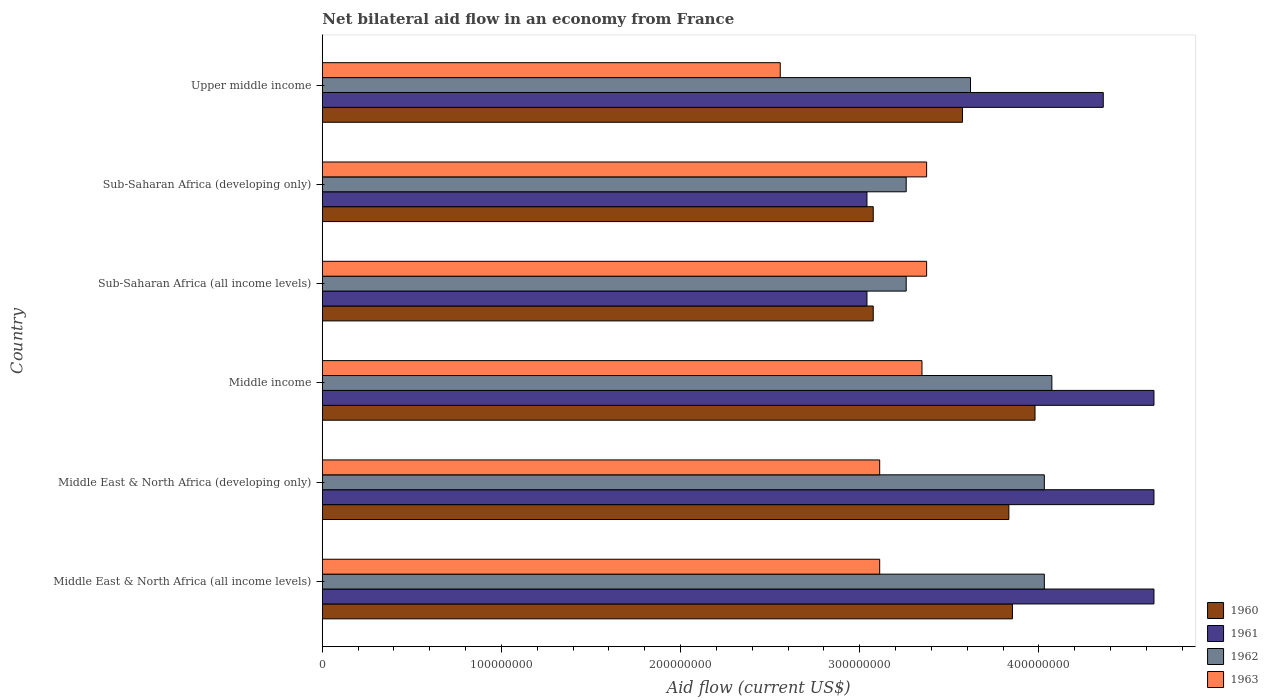Are the number of bars per tick equal to the number of legend labels?
Your answer should be compact. Yes. Are the number of bars on each tick of the Y-axis equal?
Offer a very short reply. Yes. How many bars are there on the 4th tick from the top?
Ensure brevity in your answer.  4. How many bars are there on the 2nd tick from the bottom?
Keep it short and to the point. 4. What is the label of the 5th group of bars from the top?
Make the answer very short. Middle East & North Africa (developing only). In how many cases, is the number of bars for a given country not equal to the number of legend labels?
Give a very brief answer. 0. What is the net bilateral aid flow in 1962 in Sub-Saharan Africa (all income levels)?
Give a very brief answer. 3.26e+08. Across all countries, what is the maximum net bilateral aid flow in 1962?
Provide a short and direct response. 4.07e+08. Across all countries, what is the minimum net bilateral aid flow in 1962?
Your answer should be very brief. 3.26e+08. In which country was the net bilateral aid flow in 1961 maximum?
Provide a short and direct response. Middle East & North Africa (all income levels). In which country was the net bilateral aid flow in 1962 minimum?
Ensure brevity in your answer.  Sub-Saharan Africa (all income levels). What is the total net bilateral aid flow in 1961 in the graph?
Make the answer very short. 2.44e+09. What is the difference between the net bilateral aid flow in 1962 in Middle East & North Africa (developing only) and that in Middle income?
Ensure brevity in your answer.  -4.20e+06. What is the difference between the net bilateral aid flow in 1960 in Middle income and the net bilateral aid flow in 1963 in Middle East & North Africa (developing only)?
Offer a terse response. 8.67e+07. What is the average net bilateral aid flow in 1960 per country?
Provide a short and direct response. 3.56e+08. What is the difference between the net bilateral aid flow in 1961 and net bilateral aid flow in 1963 in Middle East & North Africa (developing only)?
Keep it short and to the point. 1.53e+08. In how many countries, is the net bilateral aid flow in 1960 greater than 220000000 US$?
Make the answer very short. 6. What is the ratio of the net bilateral aid flow in 1961 in Middle income to that in Sub-Saharan Africa (all income levels)?
Your answer should be very brief. 1.53. Is the difference between the net bilateral aid flow in 1961 in Middle East & North Africa (all income levels) and Upper middle income greater than the difference between the net bilateral aid flow in 1963 in Middle East & North Africa (all income levels) and Upper middle income?
Give a very brief answer. No. What is the difference between the highest and the second highest net bilateral aid flow in 1962?
Offer a very short reply. 4.20e+06. What is the difference between the highest and the lowest net bilateral aid flow in 1960?
Keep it short and to the point. 9.03e+07. Is it the case that in every country, the sum of the net bilateral aid flow in 1962 and net bilateral aid flow in 1960 is greater than the sum of net bilateral aid flow in 1963 and net bilateral aid flow in 1961?
Provide a short and direct response. Yes. What does the 3rd bar from the top in Sub-Saharan Africa (all income levels) represents?
Provide a succinct answer. 1961. Is it the case that in every country, the sum of the net bilateral aid flow in 1962 and net bilateral aid flow in 1963 is greater than the net bilateral aid flow in 1961?
Your answer should be very brief. Yes. How many countries are there in the graph?
Provide a short and direct response. 6. Does the graph contain grids?
Give a very brief answer. No. How many legend labels are there?
Your answer should be compact. 4. How are the legend labels stacked?
Make the answer very short. Vertical. What is the title of the graph?
Keep it short and to the point. Net bilateral aid flow in an economy from France. What is the Aid flow (current US$) of 1960 in Middle East & North Africa (all income levels)?
Your response must be concise. 3.85e+08. What is the Aid flow (current US$) in 1961 in Middle East & North Africa (all income levels)?
Provide a succinct answer. 4.64e+08. What is the Aid flow (current US$) of 1962 in Middle East & North Africa (all income levels)?
Offer a very short reply. 4.03e+08. What is the Aid flow (current US$) in 1963 in Middle East & North Africa (all income levels)?
Provide a succinct answer. 3.11e+08. What is the Aid flow (current US$) of 1960 in Middle East & North Africa (developing only)?
Ensure brevity in your answer.  3.83e+08. What is the Aid flow (current US$) in 1961 in Middle East & North Africa (developing only)?
Your answer should be very brief. 4.64e+08. What is the Aid flow (current US$) in 1962 in Middle East & North Africa (developing only)?
Ensure brevity in your answer.  4.03e+08. What is the Aid flow (current US$) of 1963 in Middle East & North Africa (developing only)?
Your response must be concise. 3.11e+08. What is the Aid flow (current US$) in 1960 in Middle income?
Keep it short and to the point. 3.98e+08. What is the Aid flow (current US$) in 1961 in Middle income?
Your answer should be very brief. 4.64e+08. What is the Aid flow (current US$) of 1962 in Middle income?
Provide a succinct answer. 4.07e+08. What is the Aid flow (current US$) in 1963 in Middle income?
Offer a terse response. 3.35e+08. What is the Aid flow (current US$) in 1960 in Sub-Saharan Africa (all income levels)?
Offer a terse response. 3.08e+08. What is the Aid flow (current US$) in 1961 in Sub-Saharan Africa (all income levels)?
Make the answer very short. 3.04e+08. What is the Aid flow (current US$) in 1962 in Sub-Saharan Africa (all income levels)?
Make the answer very short. 3.26e+08. What is the Aid flow (current US$) in 1963 in Sub-Saharan Africa (all income levels)?
Offer a very short reply. 3.37e+08. What is the Aid flow (current US$) in 1960 in Sub-Saharan Africa (developing only)?
Your response must be concise. 3.08e+08. What is the Aid flow (current US$) in 1961 in Sub-Saharan Africa (developing only)?
Give a very brief answer. 3.04e+08. What is the Aid flow (current US$) of 1962 in Sub-Saharan Africa (developing only)?
Ensure brevity in your answer.  3.26e+08. What is the Aid flow (current US$) of 1963 in Sub-Saharan Africa (developing only)?
Make the answer very short. 3.37e+08. What is the Aid flow (current US$) in 1960 in Upper middle income?
Provide a succinct answer. 3.57e+08. What is the Aid flow (current US$) in 1961 in Upper middle income?
Give a very brief answer. 4.36e+08. What is the Aid flow (current US$) in 1962 in Upper middle income?
Keep it short and to the point. 3.62e+08. What is the Aid flow (current US$) in 1963 in Upper middle income?
Make the answer very short. 2.56e+08. Across all countries, what is the maximum Aid flow (current US$) in 1960?
Your answer should be very brief. 3.98e+08. Across all countries, what is the maximum Aid flow (current US$) of 1961?
Provide a short and direct response. 4.64e+08. Across all countries, what is the maximum Aid flow (current US$) in 1962?
Keep it short and to the point. 4.07e+08. Across all countries, what is the maximum Aid flow (current US$) of 1963?
Your response must be concise. 3.37e+08. Across all countries, what is the minimum Aid flow (current US$) of 1960?
Your answer should be compact. 3.08e+08. Across all countries, what is the minimum Aid flow (current US$) in 1961?
Your answer should be very brief. 3.04e+08. Across all countries, what is the minimum Aid flow (current US$) in 1962?
Ensure brevity in your answer.  3.26e+08. Across all countries, what is the minimum Aid flow (current US$) in 1963?
Provide a succinct answer. 2.56e+08. What is the total Aid flow (current US$) in 1960 in the graph?
Offer a very short reply. 2.14e+09. What is the total Aid flow (current US$) of 1961 in the graph?
Your answer should be very brief. 2.44e+09. What is the total Aid flow (current US$) in 1962 in the graph?
Ensure brevity in your answer.  2.23e+09. What is the total Aid flow (current US$) in 1963 in the graph?
Your answer should be very brief. 1.89e+09. What is the difference between the Aid flow (current US$) of 1961 in Middle East & North Africa (all income levels) and that in Middle East & North Africa (developing only)?
Make the answer very short. 0. What is the difference between the Aid flow (current US$) in 1960 in Middle East & North Africa (all income levels) and that in Middle income?
Give a very brief answer. -1.26e+07. What is the difference between the Aid flow (current US$) of 1961 in Middle East & North Africa (all income levels) and that in Middle income?
Give a very brief answer. 0. What is the difference between the Aid flow (current US$) of 1962 in Middle East & North Africa (all income levels) and that in Middle income?
Keep it short and to the point. -4.20e+06. What is the difference between the Aid flow (current US$) of 1963 in Middle East & North Africa (all income levels) and that in Middle income?
Offer a very short reply. -2.36e+07. What is the difference between the Aid flow (current US$) in 1960 in Middle East & North Africa (all income levels) and that in Sub-Saharan Africa (all income levels)?
Your response must be concise. 7.77e+07. What is the difference between the Aid flow (current US$) of 1961 in Middle East & North Africa (all income levels) and that in Sub-Saharan Africa (all income levels)?
Your answer should be compact. 1.60e+08. What is the difference between the Aid flow (current US$) of 1962 in Middle East & North Africa (all income levels) and that in Sub-Saharan Africa (all income levels)?
Give a very brief answer. 7.71e+07. What is the difference between the Aid flow (current US$) of 1963 in Middle East & North Africa (all income levels) and that in Sub-Saharan Africa (all income levels)?
Make the answer very short. -2.62e+07. What is the difference between the Aid flow (current US$) in 1960 in Middle East & North Africa (all income levels) and that in Sub-Saharan Africa (developing only)?
Give a very brief answer. 7.77e+07. What is the difference between the Aid flow (current US$) of 1961 in Middle East & North Africa (all income levels) and that in Sub-Saharan Africa (developing only)?
Your answer should be compact. 1.60e+08. What is the difference between the Aid flow (current US$) of 1962 in Middle East & North Africa (all income levels) and that in Sub-Saharan Africa (developing only)?
Your response must be concise. 7.71e+07. What is the difference between the Aid flow (current US$) in 1963 in Middle East & North Africa (all income levels) and that in Sub-Saharan Africa (developing only)?
Offer a terse response. -2.62e+07. What is the difference between the Aid flow (current US$) in 1960 in Middle East & North Africa (all income levels) and that in Upper middle income?
Offer a very short reply. 2.79e+07. What is the difference between the Aid flow (current US$) in 1961 in Middle East & North Africa (all income levels) and that in Upper middle income?
Your answer should be compact. 2.83e+07. What is the difference between the Aid flow (current US$) in 1962 in Middle East & North Africa (all income levels) and that in Upper middle income?
Keep it short and to the point. 4.12e+07. What is the difference between the Aid flow (current US$) in 1963 in Middle East & North Africa (all income levels) and that in Upper middle income?
Your response must be concise. 5.55e+07. What is the difference between the Aid flow (current US$) in 1960 in Middle East & North Africa (developing only) and that in Middle income?
Your response must be concise. -1.46e+07. What is the difference between the Aid flow (current US$) in 1962 in Middle East & North Africa (developing only) and that in Middle income?
Your answer should be very brief. -4.20e+06. What is the difference between the Aid flow (current US$) in 1963 in Middle East & North Africa (developing only) and that in Middle income?
Your answer should be compact. -2.36e+07. What is the difference between the Aid flow (current US$) in 1960 in Middle East & North Africa (developing only) and that in Sub-Saharan Africa (all income levels)?
Your answer should be compact. 7.57e+07. What is the difference between the Aid flow (current US$) of 1961 in Middle East & North Africa (developing only) and that in Sub-Saharan Africa (all income levels)?
Offer a very short reply. 1.60e+08. What is the difference between the Aid flow (current US$) of 1962 in Middle East & North Africa (developing only) and that in Sub-Saharan Africa (all income levels)?
Offer a very short reply. 7.71e+07. What is the difference between the Aid flow (current US$) in 1963 in Middle East & North Africa (developing only) and that in Sub-Saharan Africa (all income levels)?
Make the answer very short. -2.62e+07. What is the difference between the Aid flow (current US$) in 1960 in Middle East & North Africa (developing only) and that in Sub-Saharan Africa (developing only)?
Your answer should be compact. 7.57e+07. What is the difference between the Aid flow (current US$) of 1961 in Middle East & North Africa (developing only) and that in Sub-Saharan Africa (developing only)?
Your answer should be compact. 1.60e+08. What is the difference between the Aid flow (current US$) in 1962 in Middle East & North Africa (developing only) and that in Sub-Saharan Africa (developing only)?
Make the answer very short. 7.71e+07. What is the difference between the Aid flow (current US$) in 1963 in Middle East & North Africa (developing only) and that in Sub-Saharan Africa (developing only)?
Provide a short and direct response. -2.62e+07. What is the difference between the Aid flow (current US$) of 1960 in Middle East & North Africa (developing only) and that in Upper middle income?
Give a very brief answer. 2.59e+07. What is the difference between the Aid flow (current US$) in 1961 in Middle East & North Africa (developing only) and that in Upper middle income?
Ensure brevity in your answer.  2.83e+07. What is the difference between the Aid flow (current US$) of 1962 in Middle East & North Africa (developing only) and that in Upper middle income?
Ensure brevity in your answer.  4.12e+07. What is the difference between the Aid flow (current US$) in 1963 in Middle East & North Africa (developing only) and that in Upper middle income?
Provide a succinct answer. 5.55e+07. What is the difference between the Aid flow (current US$) of 1960 in Middle income and that in Sub-Saharan Africa (all income levels)?
Keep it short and to the point. 9.03e+07. What is the difference between the Aid flow (current US$) of 1961 in Middle income and that in Sub-Saharan Africa (all income levels)?
Provide a succinct answer. 1.60e+08. What is the difference between the Aid flow (current US$) of 1962 in Middle income and that in Sub-Saharan Africa (all income levels)?
Offer a very short reply. 8.13e+07. What is the difference between the Aid flow (current US$) of 1963 in Middle income and that in Sub-Saharan Africa (all income levels)?
Ensure brevity in your answer.  -2.60e+06. What is the difference between the Aid flow (current US$) of 1960 in Middle income and that in Sub-Saharan Africa (developing only)?
Your answer should be very brief. 9.03e+07. What is the difference between the Aid flow (current US$) in 1961 in Middle income and that in Sub-Saharan Africa (developing only)?
Offer a very short reply. 1.60e+08. What is the difference between the Aid flow (current US$) of 1962 in Middle income and that in Sub-Saharan Africa (developing only)?
Provide a short and direct response. 8.13e+07. What is the difference between the Aid flow (current US$) of 1963 in Middle income and that in Sub-Saharan Africa (developing only)?
Offer a terse response. -2.60e+06. What is the difference between the Aid flow (current US$) of 1960 in Middle income and that in Upper middle income?
Ensure brevity in your answer.  4.05e+07. What is the difference between the Aid flow (current US$) of 1961 in Middle income and that in Upper middle income?
Provide a succinct answer. 2.83e+07. What is the difference between the Aid flow (current US$) in 1962 in Middle income and that in Upper middle income?
Provide a short and direct response. 4.54e+07. What is the difference between the Aid flow (current US$) of 1963 in Middle income and that in Upper middle income?
Your answer should be very brief. 7.91e+07. What is the difference between the Aid flow (current US$) in 1960 in Sub-Saharan Africa (all income levels) and that in Sub-Saharan Africa (developing only)?
Provide a short and direct response. 0. What is the difference between the Aid flow (current US$) of 1961 in Sub-Saharan Africa (all income levels) and that in Sub-Saharan Africa (developing only)?
Give a very brief answer. 0. What is the difference between the Aid flow (current US$) of 1962 in Sub-Saharan Africa (all income levels) and that in Sub-Saharan Africa (developing only)?
Offer a terse response. 0. What is the difference between the Aid flow (current US$) in 1960 in Sub-Saharan Africa (all income levels) and that in Upper middle income?
Provide a succinct answer. -4.98e+07. What is the difference between the Aid flow (current US$) in 1961 in Sub-Saharan Africa (all income levels) and that in Upper middle income?
Your response must be concise. -1.32e+08. What is the difference between the Aid flow (current US$) in 1962 in Sub-Saharan Africa (all income levels) and that in Upper middle income?
Provide a short and direct response. -3.59e+07. What is the difference between the Aid flow (current US$) in 1963 in Sub-Saharan Africa (all income levels) and that in Upper middle income?
Your answer should be very brief. 8.17e+07. What is the difference between the Aid flow (current US$) in 1960 in Sub-Saharan Africa (developing only) and that in Upper middle income?
Ensure brevity in your answer.  -4.98e+07. What is the difference between the Aid flow (current US$) in 1961 in Sub-Saharan Africa (developing only) and that in Upper middle income?
Give a very brief answer. -1.32e+08. What is the difference between the Aid flow (current US$) of 1962 in Sub-Saharan Africa (developing only) and that in Upper middle income?
Provide a succinct answer. -3.59e+07. What is the difference between the Aid flow (current US$) of 1963 in Sub-Saharan Africa (developing only) and that in Upper middle income?
Offer a terse response. 8.17e+07. What is the difference between the Aid flow (current US$) of 1960 in Middle East & North Africa (all income levels) and the Aid flow (current US$) of 1961 in Middle East & North Africa (developing only)?
Your response must be concise. -7.90e+07. What is the difference between the Aid flow (current US$) in 1960 in Middle East & North Africa (all income levels) and the Aid flow (current US$) in 1962 in Middle East & North Africa (developing only)?
Offer a very short reply. -1.78e+07. What is the difference between the Aid flow (current US$) in 1960 in Middle East & North Africa (all income levels) and the Aid flow (current US$) in 1963 in Middle East & North Africa (developing only)?
Offer a very short reply. 7.41e+07. What is the difference between the Aid flow (current US$) of 1961 in Middle East & North Africa (all income levels) and the Aid flow (current US$) of 1962 in Middle East & North Africa (developing only)?
Make the answer very short. 6.12e+07. What is the difference between the Aid flow (current US$) in 1961 in Middle East & North Africa (all income levels) and the Aid flow (current US$) in 1963 in Middle East & North Africa (developing only)?
Keep it short and to the point. 1.53e+08. What is the difference between the Aid flow (current US$) of 1962 in Middle East & North Africa (all income levels) and the Aid flow (current US$) of 1963 in Middle East & North Africa (developing only)?
Keep it short and to the point. 9.19e+07. What is the difference between the Aid flow (current US$) in 1960 in Middle East & North Africa (all income levels) and the Aid flow (current US$) in 1961 in Middle income?
Your response must be concise. -7.90e+07. What is the difference between the Aid flow (current US$) of 1960 in Middle East & North Africa (all income levels) and the Aid flow (current US$) of 1962 in Middle income?
Offer a very short reply. -2.20e+07. What is the difference between the Aid flow (current US$) in 1960 in Middle East & North Africa (all income levels) and the Aid flow (current US$) in 1963 in Middle income?
Your answer should be compact. 5.05e+07. What is the difference between the Aid flow (current US$) of 1961 in Middle East & North Africa (all income levels) and the Aid flow (current US$) of 1962 in Middle income?
Keep it short and to the point. 5.70e+07. What is the difference between the Aid flow (current US$) in 1961 in Middle East & North Africa (all income levels) and the Aid flow (current US$) in 1963 in Middle income?
Your answer should be compact. 1.30e+08. What is the difference between the Aid flow (current US$) in 1962 in Middle East & North Africa (all income levels) and the Aid flow (current US$) in 1963 in Middle income?
Your response must be concise. 6.83e+07. What is the difference between the Aid flow (current US$) of 1960 in Middle East & North Africa (all income levels) and the Aid flow (current US$) of 1961 in Sub-Saharan Africa (all income levels)?
Your answer should be very brief. 8.12e+07. What is the difference between the Aid flow (current US$) in 1960 in Middle East & North Africa (all income levels) and the Aid flow (current US$) in 1962 in Sub-Saharan Africa (all income levels)?
Provide a succinct answer. 5.93e+07. What is the difference between the Aid flow (current US$) of 1960 in Middle East & North Africa (all income levels) and the Aid flow (current US$) of 1963 in Sub-Saharan Africa (all income levels)?
Keep it short and to the point. 4.79e+07. What is the difference between the Aid flow (current US$) in 1961 in Middle East & North Africa (all income levels) and the Aid flow (current US$) in 1962 in Sub-Saharan Africa (all income levels)?
Provide a short and direct response. 1.38e+08. What is the difference between the Aid flow (current US$) of 1961 in Middle East & North Africa (all income levels) and the Aid flow (current US$) of 1963 in Sub-Saharan Africa (all income levels)?
Offer a terse response. 1.27e+08. What is the difference between the Aid flow (current US$) of 1962 in Middle East & North Africa (all income levels) and the Aid flow (current US$) of 1963 in Sub-Saharan Africa (all income levels)?
Your answer should be compact. 6.57e+07. What is the difference between the Aid flow (current US$) in 1960 in Middle East & North Africa (all income levels) and the Aid flow (current US$) in 1961 in Sub-Saharan Africa (developing only)?
Ensure brevity in your answer.  8.12e+07. What is the difference between the Aid flow (current US$) of 1960 in Middle East & North Africa (all income levels) and the Aid flow (current US$) of 1962 in Sub-Saharan Africa (developing only)?
Give a very brief answer. 5.93e+07. What is the difference between the Aid flow (current US$) of 1960 in Middle East & North Africa (all income levels) and the Aid flow (current US$) of 1963 in Sub-Saharan Africa (developing only)?
Give a very brief answer. 4.79e+07. What is the difference between the Aid flow (current US$) in 1961 in Middle East & North Africa (all income levels) and the Aid flow (current US$) in 1962 in Sub-Saharan Africa (developing only)?
Offer a terse response. 1.38e+08. What is the difference between the Aid flow (current US$) in 1961 in Middle East & North Africa (all income levels) and the Aid flow (current US$) in 1963 in Sub-Saharan Africa (developing only)?
Your response must be concise. 1.27e+08. What is the difference between the Aid flow (current US$) of 1962 in Middle East & North Africa (all income levels) and the Aid flow (current US$) of 1963 in Sub-Saharan Africa (developing only)?
Provide a succinct answer. 6.57e+07. What is the difference between the Aid flow (current US$) of 1960 in Middle East & North Africa (all income levels) and the Aid flow (current US$) of 1961 in Upper middle income?
Ensure brevity in your answer.  -5.07e+07. What is the difference between the Aid flow (current US$) in 1960 in Middle East & North Africa (all income levels) and the Aid flow (current US$) in 1962 in Upper middle income?
Make the answer very short. 2.34e+07. What is the difference between the Aid flow (current US$) of 1960 in Middle East & North Africa (all income levels) and the Aid flow (current US$) of 1963 in Upper middle income?
Provide a succinct answer. 1.30e+08. What is the difference between the Aid flow (current US$) in 1961 in Middle East & North Africa (all income levels) and the Aid flow (current US$) in 1962 in Upper middle income?
Ensure brevity in your answer.  1.02e+08. What is the difference between the Aid flow (current US$) of 1961 in Middle East & North Africa (all income levels) and the Aid flow (current US$) of 1963 in Upper middle income?
Offer a terse response. 2.09e+08. What is the difference between the Aid flow (current US$) in 1962 in Middle East & North Africa (all income levels) and the Aid flow (current US$) in 1963 in Upper middle income?
Your response must be concise. 1.47e+08. What is the difference between the Aid flow (current US$) in 1960 in Middle East & North Africa (developing only) and the Aid flow (current US$) in 1961 in Middle income?
Provide a succinct answer. -8.10e+07. What is the difference between the Aid flow (current US$) in 1960 in Middle East & North Africa (developing only) and the Aid flow (current US$) in 1962 in Middle income?
Provide a succinct answer. -2.40e+07. What is the difference between the Aid flow (current US$) in 1960 in Middle East & North Africa (developing only) and the Aid flow (current US$) in 1963 in Middle income?
Give a very brief answer. 4.85e+07. What is the difference between the Aid flow (current US$) in 1961 in Middle East & North Africa (developing only) and the Aid flow (current US$) in 1962 in Middle income?
Provide a succinct answer. 5.70e+07. What is the difference between the Aid flow (current US$) in 1961 in Middle East & North Africa (developing only) and the Aid flow (current US$) in 1963 in Middle income?
Ensure brevity in your answer.  1.30e+08. What is the difference between the Aid flow (current US$) of 1962 in Middle East & North Africa (developing only) and the Aid flow (current US$) of 1963 in Middle income?
Ensure brevity in your answer.  6.83e+07. What is the difference between the Aid flow (current US$) in 1960 in Middle East & North Africa (developing only) and the Aid flow (current US$) in 1961 in Sub-Saharan Africa (all income levels)?
Offer a terse response. 7.92e+07. What is the difference between the Aid flow (current US$) of 1960 in Middle East & North Africa (developing only) and the Aid flow (current US$) of 1962 in Sub-Saharan Africa (all income levels)?
Give a very brief answer. 5.73e+07. What is the difference between the Aid flow (current US$) of 1960 in Middle East & North Africa (developing only) and the Aid flow (current US$) of 1963 in Sub-Saharan Africa (all income levels)?
Your response must be concise. 4.59e+07. What is the difference between the Aid flow (current US$) of 1961 in Middle East & North Africa (developing only) and the Aid flow (current US$) of 1962 in Sub-Saharan Africa (all income levels)?
Ensure brevity in your answer.  1.38e+08. What is the difference between the Aid flow (current US$) in 1961 in Middle East & North Africa (developing only) and the Aid flow (current US$) in 1963 in Sub-Saharan Africa (all income levels)?
Ensure brevity in your answer.  1.27e+08. What is the difference between the Aid flow (current US$) in 1962 in Middle East & North Africa (developing only) and the Aid flow (current US$) in 1963 in Sub-Saharan Africa (all income levels)?
Provide a short and direct response. 6.57e+07. What is the difference between the Aid flow (current US$) of 1960 in Middle East & North Africa (developing only) and the Aid flow (current US$) of 1961 in Sub-Saharan Africa (developing only)?
Offer a very short reply. 7.92e+07. What is the difference between the Aid flow (current US$) of 1960 in Middle East & North Africa (developing only) and the Aid flow (current US$) of 1962 in Sub-Saharan Africa (developing only)?
Keep it short and to the point. 5.73e+07. What is the difference between the Aid flow (current US$) of 1960 in Middle East & North Africa (developing only) and the Aid flow (current US$) of 1963 in Sub-Saharan Africa (developing only)?
Provide a short and direct response. 4.59e+07. What is the difference between the Aid flow (current US$) in 1961 in Middle East & North Africa (developing only) and the Aid flow (current US$) in 1962 in Sub-Saharan Africa (developing only)?
Make the answer very short. 1.38e+08. What is the difference between the Aid flow (current US$) of 1961 in Middle East & North Africa (developing only) and the Aid flow (current US$) of 1963 in Sub-Saharan Africa (developing only)?
Give a very brief answer. 1.27e+08. What is the difference between the Aid flow (current US$) in 1962 in Middle East & North Africa (developing only) and the Aid flow (current US$) in 1963 in Sub-Saharan Africa (developing only)?
Make the answer very short. 6.57e+07. What is the difference between the Aid flow (current US$) in 1960 in Middle East & North Africa (developing only) and the Aid flow (current US$) in 1961 in Upper middle income?
Your answer should be very brief. -5.27e+07. What is the difference between the Aid flow (current US$) in 1960 in Middle East & North Africa (developing only) and the Aid flow (current US$) in 1962 in Upper middle income?
Provide a short and direct response. 2.14e+07. What is the difference between the Aid flow (current US$) in 1960 in Middle East & North Africa (developing only) and the Aid flow (current US$) in 1963 in Upper middle income?
Your answer should be very brief. 1.28e+08. What is the difference between the Aid flow (current US$) of 1961 in Middle East & North Africa (developing only) and the Aid flow (current US$) of 1962 in Upper middle income?
Your answer should be compact. 1.02e+08. What is the difference between the Aid flow (current US$) of 1961 in Middle East & North Africa (developing only) and the Aid flow (current US$) of 1963 in Upper middle income?
Your answer should be compact. 2.09e+08. What is the difference between the Aid flow (current US$) of 1962 in Middle East & North Africa (developing only) and the Aid flow (current US$) of 1963 in Upper middle income?
Offer a terse response. 1.47e+08. What is the difference between the Aid flow (current US$) of 1960 in Middle income and the Aid flow (current US$) of 1961 in Sub-Saharan Africa (all income levels)?
Your answer should be very brief. 9.38e+07. What is the difference between the Aid flow (current US$) in 1960 in Middle income and the Aid flow (current US$) in 1962 in Sub-Saharan Africa (all income levels)?
Provide a succinct answer. 7.19e+07. What is the difference between the Aid flow (current US$) of 1960 in Middle income and the Aid flow (current US$) of 1963 in Sub-Saharan Africa (all income levels)?
Give a very brief answer. 6.05e+07. What is the difference between the Aid flow (current US$) in 1961 in Middle income and the Aid flow (current US$) in 1962 in Sub-Saharan Africa (all income levels)?
Provide a short and direct response. 1.38e+08. What is the difference between the Aid flow (current US$) of 1961 in Middle income and the Aid flow (current US$) of 1963 in Sub-Saharan Africa (all income levels)?
Ensure brevity in your answer.  1.27e+08. What is the difference between the Aid flow (current US$) in 1962 in Middle income and the Aid flow (current US$) in 1963 in Sub-Saharan Africa (all income levels)?
Your response must be concise. 6.99e+07. What is the difference between the Aid flow (current US$) of 1960 in Middle income and the Aid flow (current US$) of 1961 in Sub-Saharan Africa (developing only)?
Keep it short and to the point. 9.38e+07. What is the difference between the Aid flow (current US$) of 1960 in Middle income and the Aid flow (current US$) of 1962 in Sub-Saharan Africa (developing only)?
Provide a short and direct response. 7.19e+07. What is the difference between the Aid flow (current US$) of 1960 in Middle income and the Aid flow (current US$) of 1963 in Sub-Saharan Africa (developing only)?
Provide a succinct answer. 6.05e+07. What is the difference between the Aid flow (current US$) in 1961 in Middle income and the Aid flow (current US$) in 1962 in Sub-Saharan Africa (developing only)?
Give a very brief answer. 1.38e+08. What is the difference between the Aid flow (current US$) in 1961 in Middle income and the Aid flow (current US$) in 1963 in Sub-Saharan Africa (developing only)?
Give a very brief answer. 1.27e+08. What is the difference between the Aid flow (current US$) of 1962 in Middle income and the Aid flow (current US$) of 1963 in Sub-Saharan Africa (developing only)?
Ensure brevity in your answer.  6.99e+07. What is the difference between the Aid flow (current US$) of 1960 in Middle income and the Aid flow (current US$) of 1961 in Upper middle income?
Your response must be concise. -3.81e+07. What is the difference between the Aid flow (current US$) in 1960 in Middle income and the Aid flow (current US$) in 1962 in Upper middle income?
Ensure brevity in your answer.  3.60e+07. What is the difference between the Aid flow (current US$) of 1960 in Middle income and the Aid flow (current US$) of 1963 in Upper middle income?
Your response must be concise. 1.42e+08. What is the difference between the Aid flow (current US$) of 1961 in Middle income and the Aid flow (current US$) of 1962 in Upper middle income?
Ensure brevity in your answer.  1.02e+08. What is the difference between the Aid flow (current US$) of 1961 in Middle income and the Aid flow (current US$) of 1963 in Upper middle income?
Offer a very short reply. 2.09e+08. What is the difference between the Aid flow (current US$) in 1962 in Middle income and the Aid flow (current US$) in 1963 in Upper middle income?
Keep it short and to the point. 1.52e+08. What is the difference between the Aid flow (current US$) in 1960 in Sub-Saharan Africa (all income levels) and the Aid flow (current US$) in 1961 in Sub-Saharan Africa (developing only)?
Give a very brief answer. 3.50e+06. What is the difference between the Aid flow (current US$) of 1960 in Sub-Saharan Africa (all income levels) and the Aid flow (current US$) of 1962 in Sub-Saharan Africa (developing only)?
Provide a succinct answer. -1.84e+07. What is the difference between the Aid flow (current US$) in 1960 in Sub-Saharan Africa (all income levels) and the Aid flow (current US$) in 1963 in Sub-Saharan Africa (developing only)?
Offer a terse response. -2.98e+07. What is the difference between the Aid flow (current US$) of 1961 in Sub-Saharan Africa (all income levels) and the Aid flow (current US$) of 1962 in Sub-Saharan Africa (developing only)?
Provide a short and direct response. -2.19e+07. What is the difference between the Aid flow (current US$) in 1961 in Sub-Saharan Africa (all income levels) and the Aid flow (current US$) in 1963 in Sub-Saharan Africa (developing only)?
Offer a very short reply. -3.33e+07. What is the difference between the Aid flow (current US$) of 1962 in Sub-Saharan Africa (all income levels) and the Aid flow (current US$) of 1963 in Sub-Saharan Africa (developing only)?
Your response must be concise. -1.14e+07. What is the difference between the Aid flow (current US$) in 1960 in Sub-Saharan Africa (all income levels) and the Aid flow (current US$) in 1961 in Upper middle income?
Provide a succinct answer. -1.28e+08. What is the difference between the Aid flow (current US$) of 1960 in Sub-Saharan Africa (all income levels) and the Aid flow (current US$) of 1962 in Upper middle income?
Provide a succinct answer. -5.43e+07. What is the difference between the Aid flow (current US$) in 1960 in Sub-Saharan Africa (all income levels) and the Aid flow (current US$) in 1963 in Upper middle income?
Keep it short and to the point. 5.19e+07. What is the difference between the Aid flow (current US$) in 1961 in Sub-Saharan Africa (all income levels) and the Aid flow (current US$) in 1962 in Upper middle income?
Offer a terse response. -5.78e+07. What is the difference between the Aid flow (current US$) of 1961 in Sub-Saharan Africa (all income levels) and the Aid flow (current US$) of 1963 in Upper middle income?
Keep it short and to the point. 4.84e+07. What is the difference between the Aid flow (current US$) in 1962 in Sub-Saharan Africa (all income levels) and the Aid flow (current US$) in 1963 in Upper middle income?
Keep it short and to the point. 7.03e+07. What is the difference between the Aid flow (current US$) in 1960 in Sub-Saharan Africa (developing only) and the Aid flow (current US$) in 1961 in Upper middle income?
Make the answer very short. -1.28e+08. What is the difference between the Aid flow (current US$) in 1960 in Sub-Saharan Africa (developing only) and the Aid flow (current US$) in 1962 in Upper middle income?
Make the answer very short. -5.43e+07. What is the difference between the Aid flow (current US$) of 1960 in Sub-Saharan Africa (developing only) and the Aid flow (current US$) of 1963 in Upper middle income?
Make the answer very short. 5.19e+07. What is the difference between the Aid flow (current US$) in 1961 in Sub-Saharan Africa (developing only) and the Aid flow (current US$) in 1962 in Upper middle income?
Your answer should be compact. -5.78e+07. What is the difference between the Aid flow (current US$) of 1961 in Sub-Saharan Africa (developing only) and the Aid flow (current US$) of 1963 in Upper middle income?
Offer a very short reply. 4.84e+07. What is the difference between the Aid flow (current US$) of 1962 in Sub-Saharan Africa (developing only) and the Aid flow (current US$) of 1963 in Upper middle income?
Provide a short and direct response. 7.03e+07. What is the average Aid flow (current US$) of 1960 per country?
Keep it short and to the point. 3.56e+08. What is the average Aid flow (current US$) in 1961 per country?
Provide a short and direct response. 4.06e+08. What is the average Aid flow (current US$) of 1962 per country?
Provide a succinct answer. 3.71e+08. What is the average Aid flow (current US$) in 1963 per country?
Keep it short and to the point. 3.15e+08. What is the difference between the Aid flow (current US$) of 1960 and Aid flow (current US$) of 1961 in Middle East & North Africa (all income levels)?
Provide a short and direct response. -7.90e+07. What is the difference between the Aid flow (current US$) in 1960 and Aid flow (current US$) in 1962 in Middle East & North Africa (all income levels)?
Your response must be concise. -1.78e+07. What is the difference between the Aid flow (current US$) of 1960 and Aid flow (current US$) of 1963 in Middle East & North Africa (all income levels)?
Provide a short and direct response. 7.41e+07. What is the difference between the Aid flow (current US$) of 1961 and Aid flow (current US$) of 1962 in Middle East & North Africa (all income levels)?
Your response must be concise. 6.12e+07. What is the difference between the Aid flow (current US$) in 1961 and Aid flow (current US$) in 1963 in Middle East & North Africa (all income levels)?
Provide a succinct answer. 1.53e+08. What is the difference between the Aid flow (current US$) in 1962 and Aid flow (current US$) in 1963 in Middle East & North Africa (all income levels)?
Keep it short and to the point. 9.19e+07. What is the difference between the Aid flow (current US$) of 1960 and Aid flow (current US$) of 1961 in Middle East & North Africa (developing only)?
Offer a very short reply. -8.10e+07. What is the difference between the Aid flow (current US$) of 1960 and Aid flow (current US$) of 1962 in Middle East & North Africa (developing only)?
Your answer should be compact. -1.98e+07. What is the difference between the Aid flow (current US$) in 1960 and Aid flow (current US$) in 1963 in Middle East & North Africa (developing only)?
Your answer should be very brief. 7.21e+07. What is the difference between the Aid flow (current US$) in 1961 and Aid flow (current US$) in 1962 in Middle East & North Africa (developing only)?
Provide a succinct answer. 6.12e+07. What is the difference between the Aid flow (current US$) in 1961 and Aid flow (current US$) in 1963 in Middle East & North Africa (developing only)?
Your answer should be very brief. 1.53e+08. What is the difference between the Aid flow (current US$) in 1962 and Aid flow (current US$) in 1963 in Middle East & North Africa (developing only)?
Make the answer very short. 9.19e+07. What is the difference between the Aid flow (current US$) of 1960 and Aid flow (current US$) of 1961 in Middle income?
Offer a terse response. -6.64e+07. What is the difference between the Aid flow (current US$) of 1960 and Aid flow (current US$) of 1962 in Middle income?
Offer a very short reply. -9.40e+06. What is the difference between the Aid flow (current US$) in 1960 and Aid flow (current US$) in 1963 in Middle income?
Give a very brief answer. 6.31e+07. What is the difference between the Aid flow (current US$) of 1961 and Aid flow (current US$) of 1962 in Middle income?
Your answer should be very brief. 5.70e+07. What is the difference between the Aid flow (current US$) in 1961 and Aid flow (current US$) in 1963 in Middle income?
Your answer should be very brief. 1.30e+08. What is the difference between the Aid flow (current US$) of 1962 and Aid flow (current US$) of 1963 in Middle income?
Your response must be concise. 7.25e+07. What is the difference between the Aid flow (current US$) in 1960 and Aid flow (current US$) in 1961 in Sub-Saharan Africa (all income levels)?
Your answer should be compact. 3.50e+06. What is the difference between the Aid flow (current US$) of 1960 and Aid flow (current US$) of 1962 in Sub-Saharan Africa (all income levels)?
Your answer should be very brief. -1.84e+07. What is the difference between the Aid flow (current US$) of 1960 and Aid flow (current US$) of 1963 in Sub-Saharan Africa (all income levels)?
Provide a succinct answer. -2.98e+07. What is the difference between the Aid flow (current US$) of 1961 and Aid flow (current US$) of 1962 in Sub-Saharan Africa (all income levels)?
Your response must be concise. -2.19e+07. What is the difference between the Aid flow (current US$) of 1961 and Aid flow (current US$) of 1963 in Sub-Saharan Africa (all income levels)?
Your response must be concise. -3.33e+07. What is the difference between the Aid flow (current US$) of 1962 and Aid flow (current US$) of 1963 in Sub-Saharan Africa (all income levels)?
Keep it short and to the point. -1.14e+07. What is the difference between the Aid flow (current US$) of 1960 and Aid flow (current US$) of 1961 in Sub-Saharan Africa (developing only)?
Offer a very short reply. 3.50e+06. What is the difference between the Aid flow (current US$) in 1960 and Aid flow (current US$) in 1962 in Sub-Saharan Africa (developing only)?
Keep it short and to the point. -1.84e+07. What is the difference between the Aid flow (current US$) in 1960 and Aid flow (current US$) in 1963 in Sub-Saharan Africa (developing only)?
Make the answer very short. -2.98e+07. What is the difference between the Aid flow (current US$) of 1961 and Aid flow (current US$) of 1962 in Sub-Saharan Africa (developing only)?
Keep it short and to the point. -2.19e+07. What is the difference between the Aid flow (current US$) in 1961 and Aid flow (current US$) in 1963 in Sub-Saharan Africa (developing only)?
Offer a very short reply. -3.33e+07. What is the difference between the Aid flow (current US$) in 1962 and Aid flow (current US$) in 1963 in Sub-Saharan Africa (developing only)?
Your response must be concise. -1.14e+07. What is the difference between the Aid flow (current US$) in 1960 and Aid flow (current US$) in 1961 in Upper middle income?
Your answer should be very brief. -7.86e+07. What is the difference between the Aid flow (current US$) of 1960 and Aid flow (current US$) of 1962 in Upper middle income?
Your response must be concise. -4.50e+06. What is the difference between the Aid flow (current US$) of 1960 and Aid flow (current US$) of 1963 in Upper middle income?
Keep it short and to the point. 1.02e+08. What is the difference between the Aid flow (current US$) in 1961 and Aid flow (current US$) in 1962 in Upper middle income?
Your answer should be compact. 7.41e+07. What is the difference between the Aid flow (current US$) in 1961 and Aid flow (current US$) in 1963 in Upper middle income?
Ensure brevity in your answer.  1.80e+08. What is the difference between the Aid flow (current US$) of 1962 and Aid flow (current US$) of 1963 in Upper middle income?
Your answer should be compact. 1.06e+08. What is the ratio of the Aid flow (current US$) in 1960 in Middle East & North Africa (all income levels) to that in Middle East & North Africa (developing only)?
Your answer should be very brief. 1.01. What is the ratio of the Aid flow (current US$) of 1961 in Middle East & North Africa (all income levels) to that in Middle East & North Africa (developing only)?
Provide a short and direct response. 1. What is the ratio of the Aid flow (current US$) in 1962 in Middle East & North Africa (all income levels) to that in Middle East & North Africa (developing only)?
Your answer should be very brief. 1. What is the ratio of the Aid flow (current US$) in 1960 in Middle East & North Africa (all income levels) to that in Middle income?
Keep it short and to the point. 0.97. What is the ratio of the Aid flow (current US$) in 1961 in Middle East & North Africa (all income levels) to that in Middle income?
Offer a very short reply. 1. What is the ratio of the Aid flow (current US$) in 1962 in Middle East & North Africa (all income levels) to that in Middle income?
Keep it short and to the point. 0.99. What is the ratio of the Aid flow (current US$) of 1963 in Middle East & North Africa (all income levels) to that in Middle income?
Provide a succinct answer. 0.93. What is the ratio of the Aid flow (current US$) in 1960 in Middle East & North Africa (all income levels) to that in Sub-Saharan Africa (all income levels)?
Your answer should be compact. 1.25. What is the ratio of the Aid flow (current US$) in 1961 in Middle East & North Africa (all income levels) to that in Sub-Saharan Africa (all income levels)?
Provide a succinct answer. 1.53. What is the ratio of the Aid flow (current US$) in 1962 in Middle East & North Africa (all income levels) to that in Sub-Saharan Africa (all income levels)?
Provide a short and direct response. 1.24. What is the ratio of the Aid flow (current US$) in 1963 in Middle East & North Africa (all income levels) to that in Sub-Saharan Africa (all income levels)?
Offer a very short reply. 0.92. What is the ratio of the Aid flow (current US$) in 1960 in Middle East & North Africa (all income levels) to that in Sub-Saharan Africa (developing only)?
Make the answer very short. 1.25. What is the ratio of the Aid flow (current US$) in 1961 in Middle East & North Africa (all income levels) to that in Sub-Saharan Africa (developing only)?
Provide a succinct answer. 1.53. What is the ratio of the Aid flow (current US$) of 1962 in Middle East & North Africa (all income levels) to that in Sub-Saharan Africa (developing only)?
Offer a terse response. 1.24. What is the ratio of the Aid flow (current US$) of 1963 in Middle East & North Africa (all income levels) to that in Sub-Saharan Africa (developing only)?
Offer a very short reply. 0.92. What is the ratio of the Aid flow (current US$) of 1960 in Middle East & North Africa (all income levels) to that in Upper middle income?
Your answer should be very brief. 1.08. What is the ratio of the Aid flow (current US$) of 1961 in Middle East & North Africa (all income levels) to that in Upper middle income?
Offer a very short reply. 1.06. What is the ratio of the Aid flow (current US$) in 1962 in Middle East & North Africa (all income levels) to that in Upper middle income?
Ensure brevity in your answer.  1.11. What is the ratio of the Aid flow (current US$) of 1963 in Middle East & North Africa (all income levels) to that in Upper middle income?
Offer a terse response. 1.22. What is the ratio of the Aid flow (current US$) in 1960 in Middle East & North Africa (developing only) to that in Middle income?
Provide a short and direct response. 0.96. What is the ratio of the Aid flow (current US$) of 1961 in Middle East & North Africa (developing only) to that in Middle income?
Provide a succinct answer. 1. What is the ratio of the Aid flow (current US$) in 1962 in Middle East & North Africa (developing only) to that in Middle income?
Provide a short and direct response. 0.99. What is the ratio of the Aid flow (current US$) of 1963 in Middle East & North Africa (developing only) to that in Middle income?
Make the answer very short. 0.93. What is the ratio of the Aid flow (current US$) of 1960 in Middle East & North Africa (developing only) to that in Sub-Saharan Africa (all income levels)?
Your response must be concise. 1.25. What is the ratio of the Aid flow (current US$) in 1961 in Middle East & North Africa (developing only) to that in Sub-Saharan Africa (all income levels)?
Give a very brief answer. 1.53. What is the ratio of the Aid flow (current US$) in 1962 in Middle East & North Africa (developing only) to that in Sub-Saharan Africa (all income levels)?
Give a very brief answer. 1.24. What is the ratio of the Aid flow (current US$) in 1963 in Middle East & North Africa (developing only) to that in Sub-Saharan Africa (all income levels)?
Give a very brief answer. 0.92. What is the ratio of the Aid flow (current US$) of 1960 in Middle East & North Africa (developing only) to that in Sub-Saharan Africa (developing only)?
Give a very brief answer. 1.25. What is the ratio of the Aid flow (current US$) of 1961 in Middle East & North Africa (developing only) to that in Sub-Saharan Africa (developing only)?
Your response must be concise. 1.53. What is the ratio of the Aid flow (current US$) of 1962 in Middle East & North Africa (developing only) to that in Sub-Saharan Africa (developing only)?
Give a very brief answer. 1.24. What is the ratio of the Aid flow (current US$) of 1963 in Middle East & North Africa (developing only) to that in Sub-Saharan Africa (developing only)?
Offer a very short reply. 0.92. What is the ratio of the Aid flow (current US$) in 1960 in Middle East & North Africa (developing only) to that in Upper middle income?
Your response must be concise. 1.07. What is the ratio of the Aid flow (current US$) of 1961 in Middle East & North Africa (developing only) to that in Upper middle income?
Give a very brief answer. 1.06. What is the ratio of the Aid flow (current US$) in 1962 in Middle East & North Africa (developing only) to that in Upper middle income?
Provide a short and direct response. 1.11. What is the ratio of the Aid flow (current US$) in 1963 in Middle East & North Africa (developing only) to that in Upper middle income?
Make the answer very short. 1.22. What is the ratio of the Aid flow (current US$) in 1960 in Middle income to that in Sub-Saharan Africa (all income levels)?
Your answer should be very brief. 1.29. What is the ratio of the Aid flow (current US$) in 1961 in Middle income to that in Sub-Saharan Africa (all income levels)?
Provide a short and direct response. 1.53. What is the ratio of the Aid flow (current US$) of 1962 in Middle income to that in Sub-Saharan Africa (all income levels)?
Your answer should be very brief. 1.25. What is the ratio of the Aid flow (current US$) of 1960 in Middle income to that in Sub-Saharan Africa (developing only)?
Provide a succinct answer. 1.29. What is the ratio of the Aid flow (current US$) in 1961 in Middle income to that in Sub-Saharan Africa (developing only)?
Keep it short and to the point. 1.53. What is the ratio of the Aid flow (current US$) of 1962 in Middle income to that in Sub-Saharan Africa (developing only)?
Give a very brief answer. 1.25. What is the ratio of the Aid flow (current US$) of 1963 in Middle income to that in Sub-Saharan Africa (developing only)?
Provide a succinct answer. 0.99. What is the ratio of the Aid flow (current US$) in 1960 in Middle income to that in Upper middle income?
Offer a terse response. 1.11. What is the ratio of the Aid flow (current US$) of 1961 in Middle income to that in Upper middle income?
Your answer should be compact. 1.06. What is the ratio of the Aid flow (current US$) of 1962 in Middle income to that in Upper middle income?
Keep it short and to the point. 1.13. What is the ratio of the Aid flow (current US$) in 1963 in Middle income to that in Upper middle income?
Your answer should be compact. 1.31. What is the ratio of the Aid flow (current US$) of 1960 in Sub-Saharan Africa (all income levels) to that in Sub-Saharan Africa (developing only)?
Offer a very short reply. 1. What is the ratio of the Aid flow (current US$) of 1962 in Sub-Saharan Africa (all income levels) to that in Sub-Saharan Africa (developing only)?
Provide a short and direct response. 1. What is the ratio of the Aid flow (current US$) in 1960 in Sub-Saharan Africa (all income levels) to that in Upper middle income?
Provide a short and direct response. 0.86. What is the ratio of the Aid flow (current US$) of 1961 in Sub-Saharan Africa (all income levels) to that in Upper middle income?
Your answer should be compact. 0.7. What is the ratio of the Aid flow (current US$) of 1962 in Sub-Saharan Africa (all income levels) to that in Upper middle income?
Offer a very short reply. 0.9. What is the ratio of the Aid flow (current US$) in 1963 in Sub-Saharan Africa (all income levels) to that in Upper middle income?
Your answer should be compact. 1.32. What is the ratio of the Aid flow (current US$) in 1960 in Sub-Saharan Africa (developing only) to that in Upper middle income?
Ensure brevity in your answer.  0.86. What is the ratio of the Aid flow (current US$) of 1961 in Sub-Saharan Africa (developing only) to that in Upper middle income?
Provide a succinct answer. 0.7. What is the ratio of the Aid flow (current US$) of 1962 in Sub-Saharan Africa (developing only) to that in Upper middle income?
Make the answer very short. 0.9. What is the ratio of the Aid flow (current US$) in 1963 in Sub-Saharan Africa (developing only) to that in Upper middle income?
Offer a very short reply. 1.32. What is the difference between the highest and the second highest Aid flow (current US$) in 1960?
Give a very brief answer. 1.26e+07. What is the difference between the highest and the second highest Aid flow (current US$) in 1962?
Provide a short and direct response. 4.20e+06. What is the difference between the highest and the second highest Aid flow (current US$) of 1963?
Your answer should be very brief. 0. What is the difference between the highest and the lowest Aid flow (current US$) in 1960?
Provide a succinct answer. 9.03e+07. What is the difference between the highest and the lowest Aid flow (current US$) in 1961?
Give a very brief answer. 1.60e+08. What is the difference between the highest and the lowest Aid flow (current US$) of 1962?
Your answer should be compact. 8.13e+07. What is the difference between the highest and the lowest Aid flow (current US$) in 1963?
Give a very brief answer. 8.17e+07. 